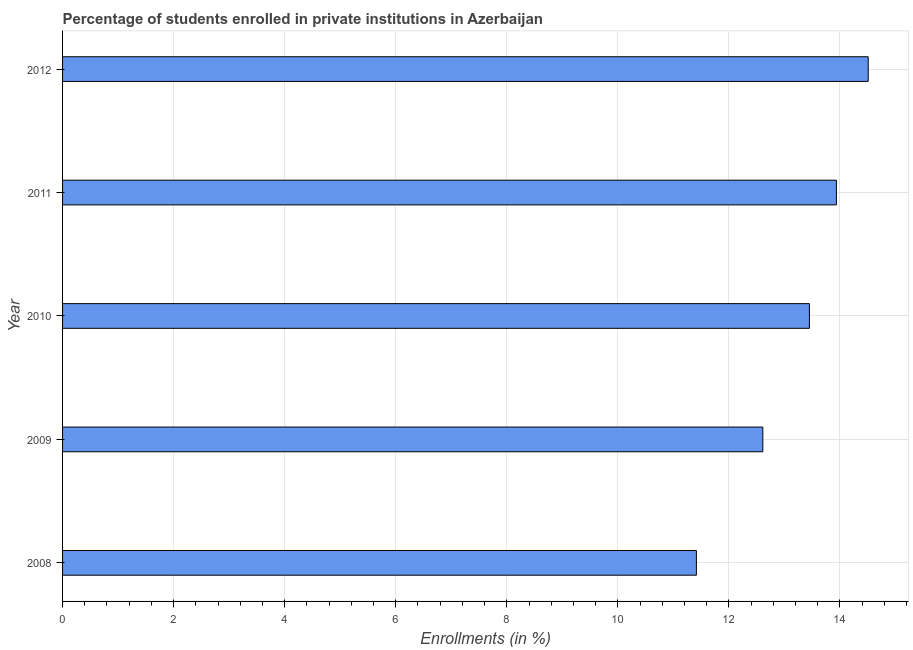Does the graph contain grids?
Make the answer very short. Yes. What is the title of the graph?
Ensure brevity in your answer.  Percentage of students enrolled in private institutions in Azerbaijan. What is the label or title of the X-axis?
Make the answer very short. Enrollments (in %). What is the enrollments in private institutions in 2012?
Keep it short and to the point. 14.51. Across all years, what is the maximum enrollments in private institutions?
Ensure brevity in your answer.  14.51. Across all years, what is the minimum enrollments in private institutions?
Your answer should be very brief. 11.41. In which year was the enrollments in private institutions minimum?
Keep it short and to the point. 2008. What is the sum of the enrollments in private institutions?
Give a very brief answer. 65.92. What is the difference between the enrollments in private institutions in 2009 and 2012?
Ensure brevity in your answer.  -1.9. What is the average enrollments in private institutions per year?
Ensure brevity in your answer.  13.18. What is the median enrollments in private institutions?
Provide a short and direct response. 13.45. In how many years, is the enrollments in private institutions greater than 8.8 %?
Your answer should be very brief. 5. Do a majority of the years between 2011 and 2012 (inclusive) have enrollments in private institutions greater than 13.2 %?
Your answer should be very brief. Yes. What is the ratio of the enrollments in private institutions in 2009 to that in 2010?
Offer a very short reply. 0.94. Is the enrollments in private institutions in 2008 less than that in 2012?
Give a very brief answer. Yes. What is the difference between the highest and the second highest enrollments in private institutions?
Ensure brevity in your answer.  0.57. What is the difference between the highest and the lowest enrollments in private institutions?
Your response must be concise. 3.09. How many bars are there?
Give a very brief answer. 5. Are the values on the major ticks of X-axis written in scientific E-notation?
Offer a terse response. No. What is the Enrollments (in %) of 2008?
Provide a succinct answer. 11.41. What is the Enrollments (in %) in 2009?
Your answer should be compact. 12.61. What is the Enrollments (in %) in 2010?
Keep it short and to the point. 13.45. What is the Enrollments (in %) in 2011?
Keep it short and to the point. 13.94. What is the Enrollments (in %) in 2012?
Keep it short and to the point. 14.51. What is the difference between the Enrollments (in %) in 2008 and 2009?
Your answer should be very brief. -1.2. What is the difference between the Enrollments (in %) in 2008 and 2010?
Ensure brevity in your answer.  -2.04. What is the difference between the Enrollments (in %) in 2008 and 2011?
Your answer should be very brief. -2.52. What is the difference between the Enrollments (in %) in 2008 and 2012?
Ensure brevity in your answer.  -3.09. What is the difference between the Enrollments (in %) in 2009 and 2010?
Offer a very short reply. -0.84. What is the difference between the Enrollments (in %) in 2009 and 2011?
Your answer should be compact. -1.32. What is the difference between the Enrollments (in %) in 2009 and 2012?
Your answer should be very brief. -1.9. What is the difference between the Enrollments (in %) in 2010 and 2011?
Offer a terse response. -0.49. What is the difference between the Enrollments (in %) in 2010 and 2012?
Provide a short and direct response. -1.06. What is the difference between the Enrollments (in %) in 2011 and 2012?
Your response must be concise. -0.57. What is the ratio of the Enrollments (in %) in 2008 to that in 2009?
Keep it short and to the point. 0.91. What is the ratio of the Enrollments (in %) in 2008 to that in 2010?
Offer a terse response. 0.85. What is the ratio of the Enrollments (in %) in 2008 to that in 2011?
Offer a very short reply. 0.82. What is the ratio of the Enrollments (in %) in 2008 to that in 2012?
Your answer should be compact. 0.79. What is the ratio of the Enrollments (in %) in 2009 to that in 2010?
Give a very brief answer. 0.94. What is the ratio of the Enrollments (in %) in 2009 to that in 2011?
Offer a very short reply. 0.91. What is the ratio of the Enrollments (in %) in 2009 to that in 2012?
Provide a succinct answer. 0.87. What is the ratio of the Enrollments (in %) in 2010 to that in 2012?
Ensure brevity in your answer.  0.93. What is the ratio of the Enrollments (in %) in 2011 to that in 2012?
Your response must be concise. 0.96. 